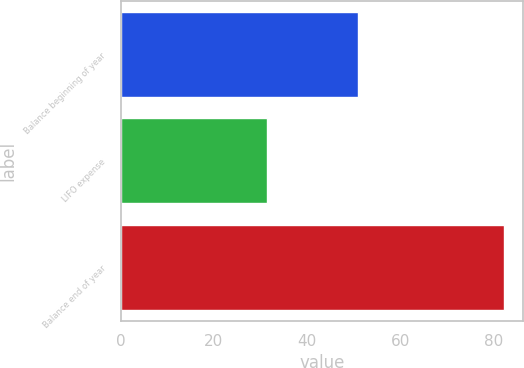Convert chart. <chart><loc_0><loc_0><loc_500><loc_500><bar_chart><fcel>Balance beginning of year<fcel>LIFO expense<fcel>Balance end of year<nl><fcel>50.9<fcel>31.3<fcel>82.2<nl></chart> 